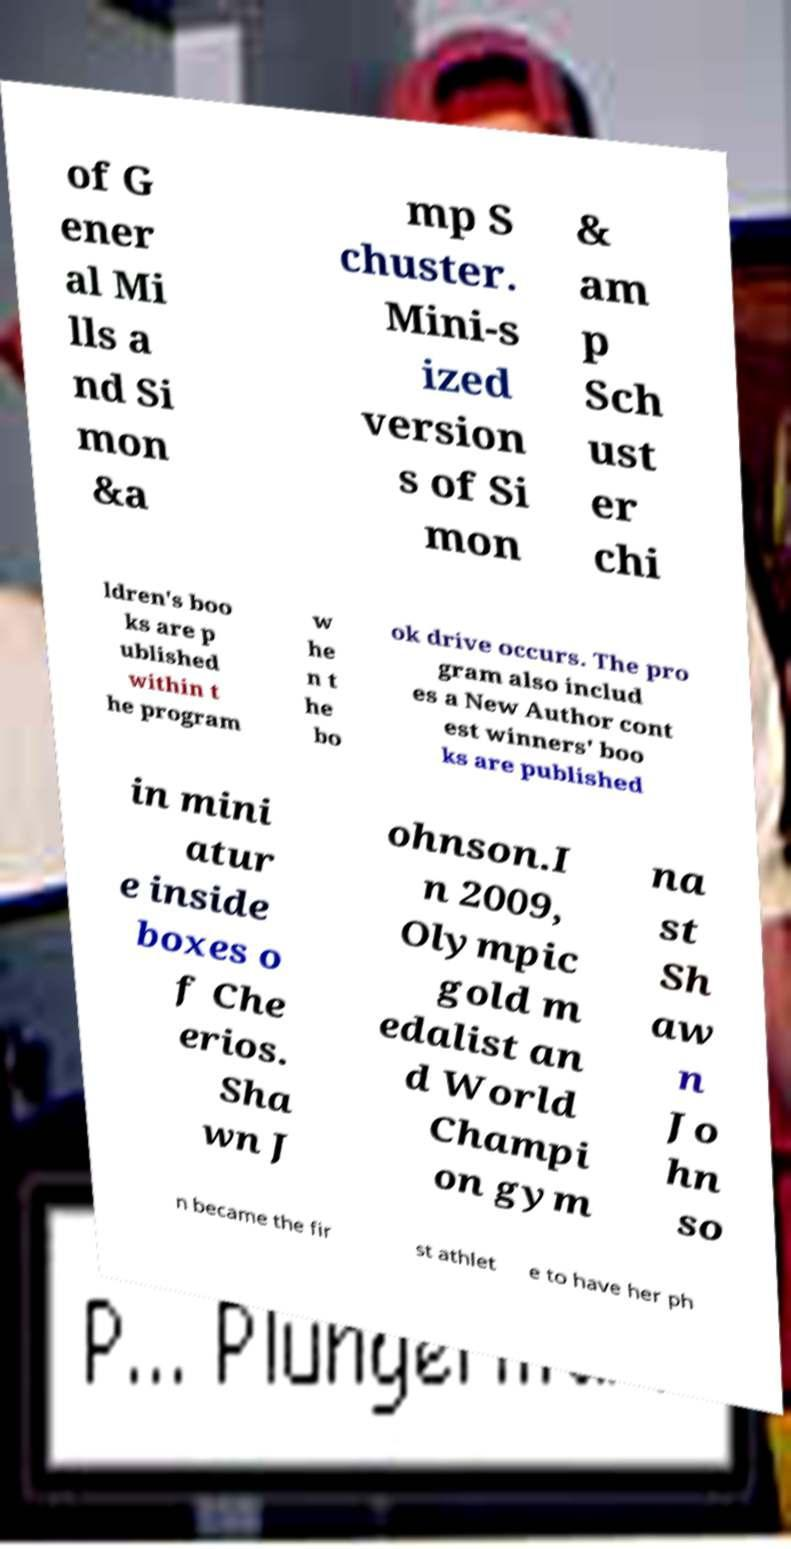What messages or text are displayed in this image? I need them in a readable, typed format. of G ener al Mi lls a nd Si mon &a mp S chuster. Mini-s ized version s of Si mon & am p Sch ust er chi ldren's boo ks are p ublished within t he program w he n t he bo ok drive occurs. The pro gram also includ es a New Author cont est winners' boo ks are published in mini atur e inside boxes o f Che erios. Sha wn J ohnson.I n 2009, Olympic gold m edalist an d World Champi on gym na st Sh aw n Jo hn so n became the fir st athlet e to have her ph 